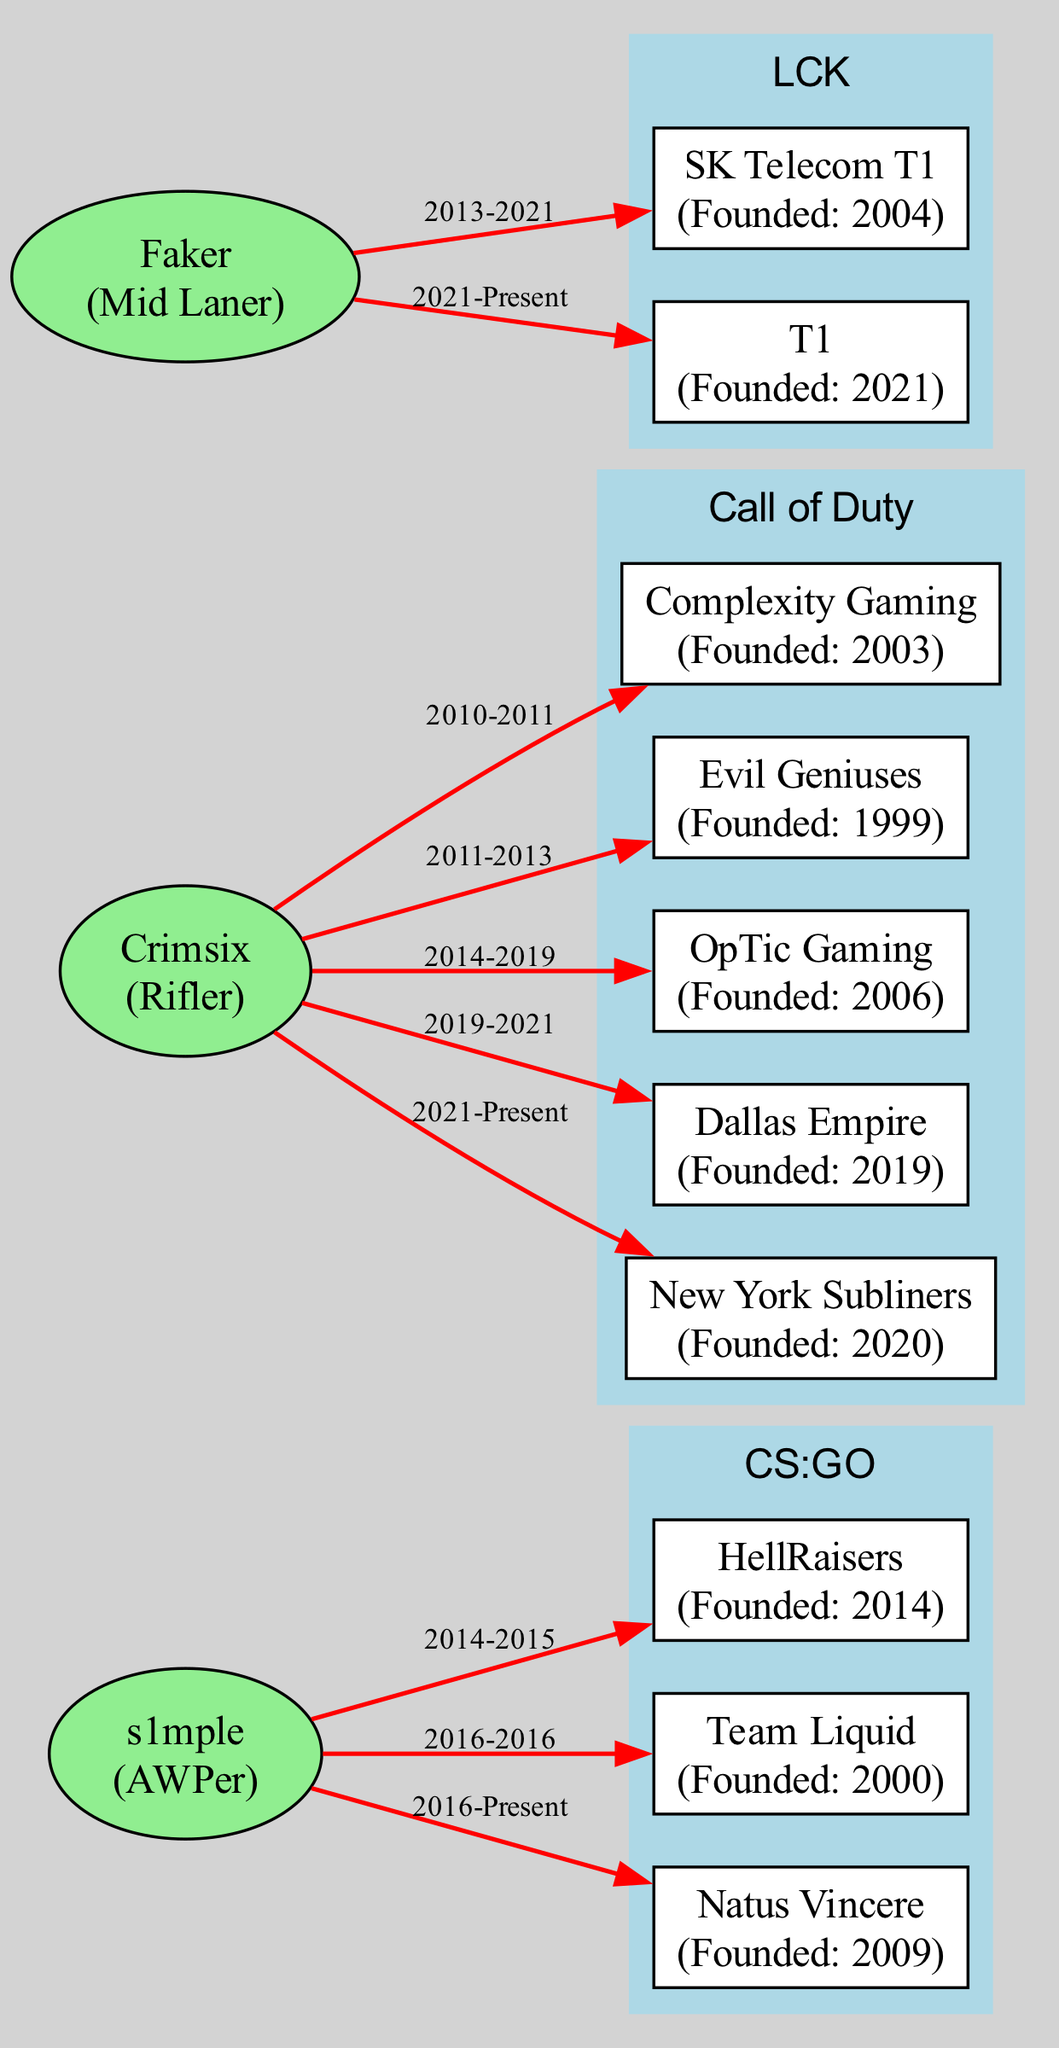What is the total number of players displayed in the diagram? The diagram lists three players: Faker, s1mple, and Crimsix. By counting those names, we find that there are three players depicted in the diagram.
Answer: 3 Which team did Faker first join? According to the teams associated with Faker, he first joined SK Telecom T1 in 2013. Therefore, SK Telecom T1 is the team he first joined.
Answer: SK Telecom T1 How many teams did Crimsix play for in total? Crimsix played for five teams: Complexity Gaming, Evil Geniuses, OpTic Gaming, Dallas Empire, and New York Subliners. Counting each team gives us a total of five teams.
Answer: 5 What is the founding year of Natus Vincere? The diagram states that Natus Vincere was founded in 2009, which is explicitly mentioned alongside the team's details.
Answer: 2009 Who is the player with the AWPer role? The diagram indicates that the player designated as the AWPer is s1mple, as noted alongside his role when displaying player information.
Answer: s1mple Which team has had Faker since 2021? The diagram shows that Faker has been with the team T1 since 2021, clearly indicated in his team history.
Answer: T1 What league does OpTic Gaming compete in? According to the diagram, OpTic Gaming is associated with the Call of Duty league, as shown in the team’s details.
Answer: Call of Duty Which player has the longest continuous tenure with a team? By evaluating the time frames, we find that s1mple has been with Natus Vincere since 2016 and continues to play for them, making his tenure the longest.
Answer: s1mple How many teams has s1mple played for before joining Natus Vincere? Before joining Natus Vincere in 2016, s1mple played for two teams: HellRaisers (2014-2015) and Team Liquid (2016). Counting these gives us two teams.
Answer: 2 